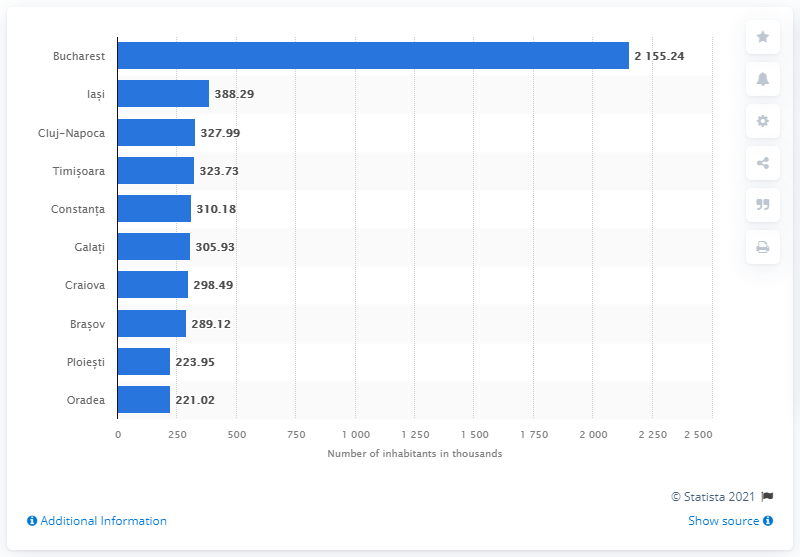Mention a couple of crucial points in this snapshot. In 2020, Bucharest was the Romanian city with the most permanent residents. 